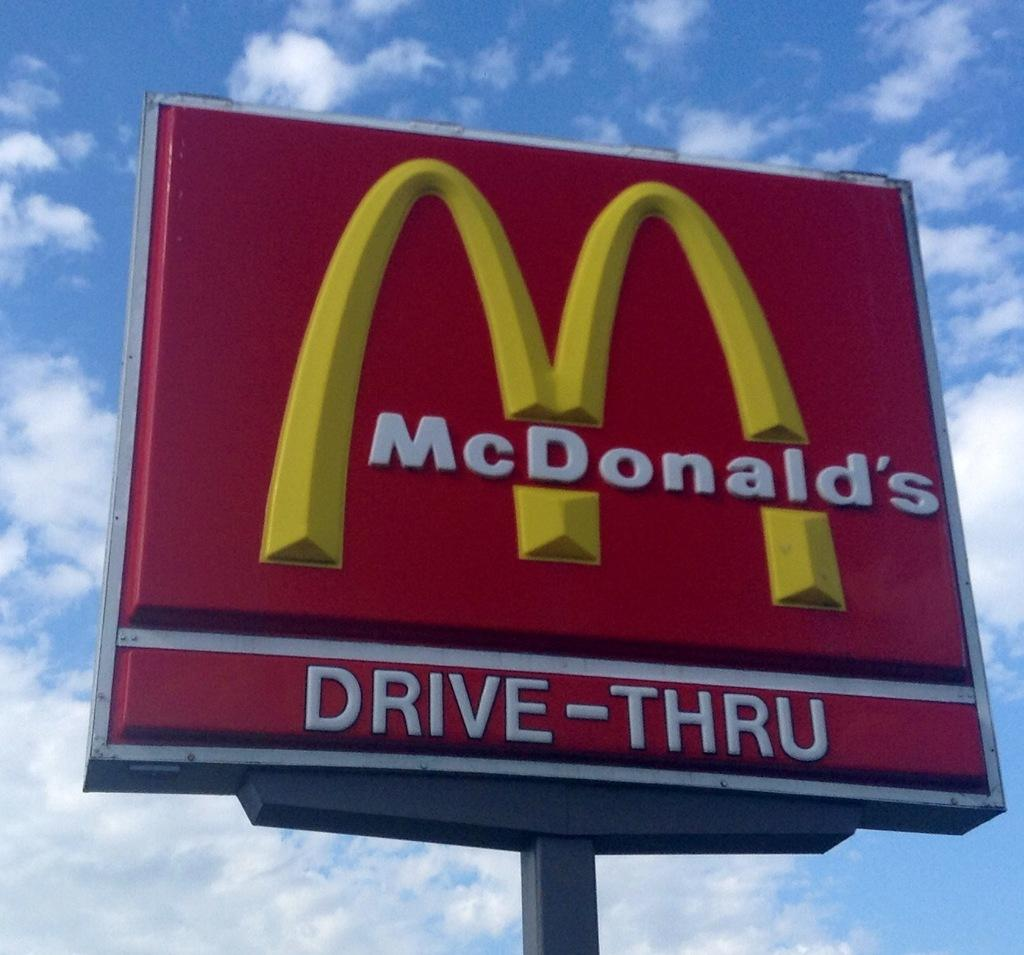<image>
Render a clear and concise summary of the photo. A large outdoor Mcdonald's sign against a daytime blue sky. 